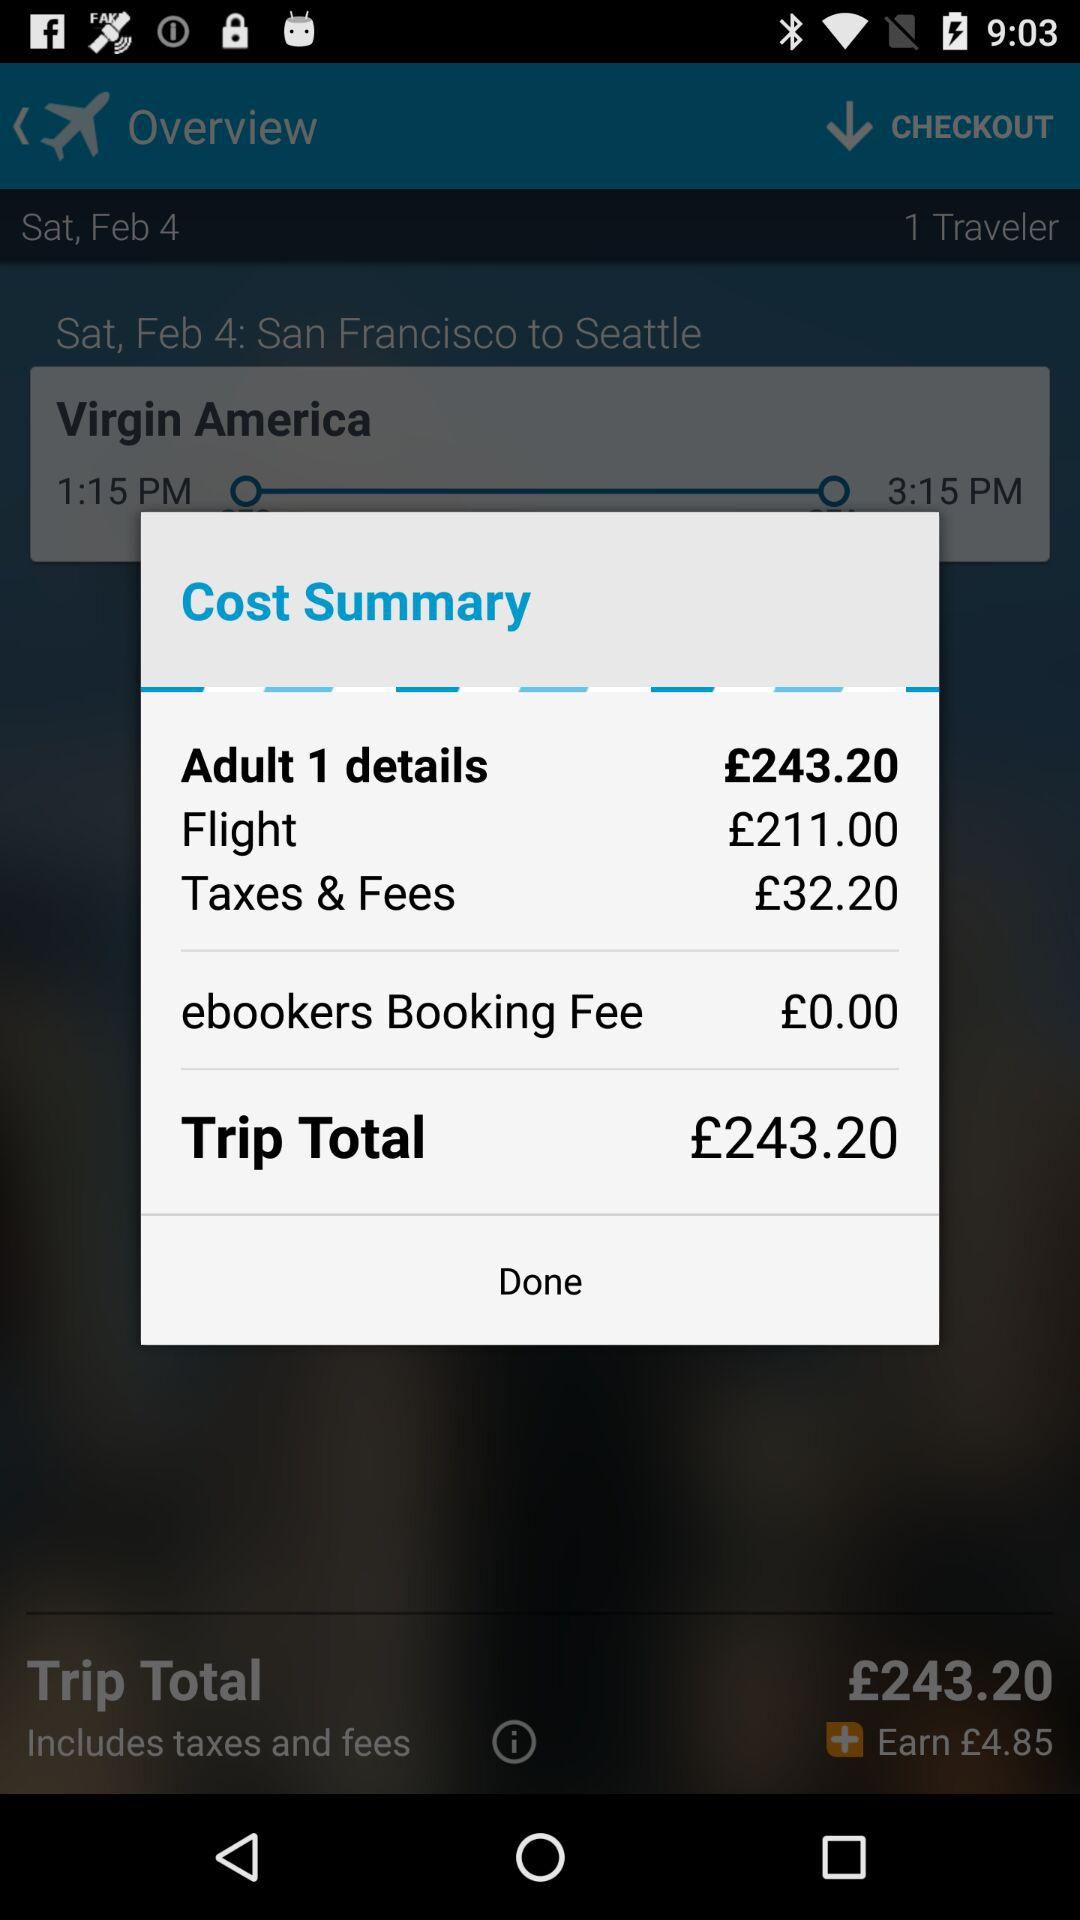What is the ebookers booking fee? The ebookers booking fee £0.00. 